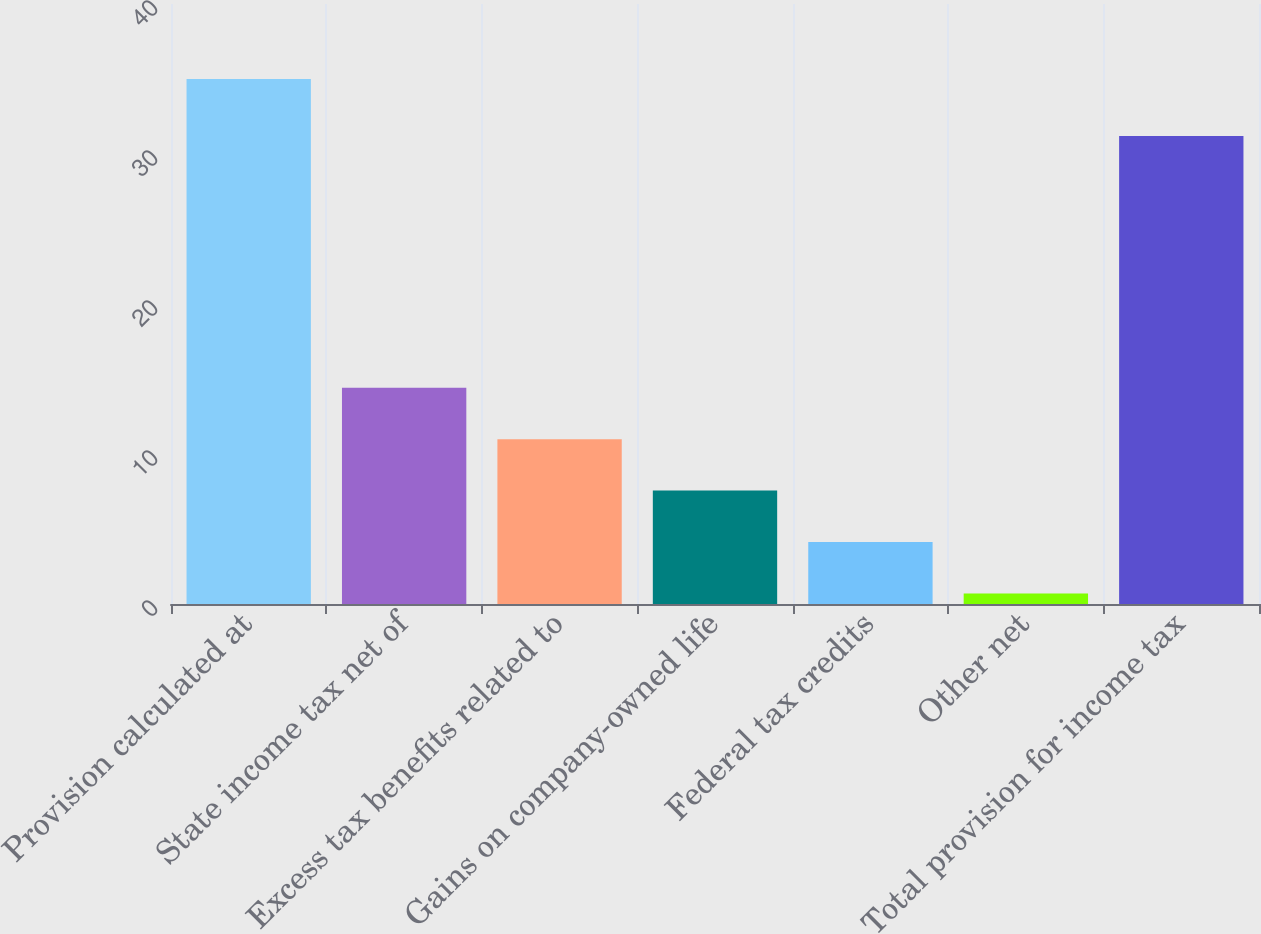Convert chart to OTSL. <chart><loc_0><loc_0><loc_500><loc_500><bar_chart><fcel>Provision calculated at<fcel>State income tax net of<fcel>Excess tax benefits related to<fcel>Gains on company-owned life<fcel>Federal tax credits<fcel>Other net<fcel>Total provision for income tax<nl><fcel>35<fcel>14.42<fcel>10.99<fcel>7.56<fcel>4.13<fcel>0.7<fcel>31.2<nl></chart> 